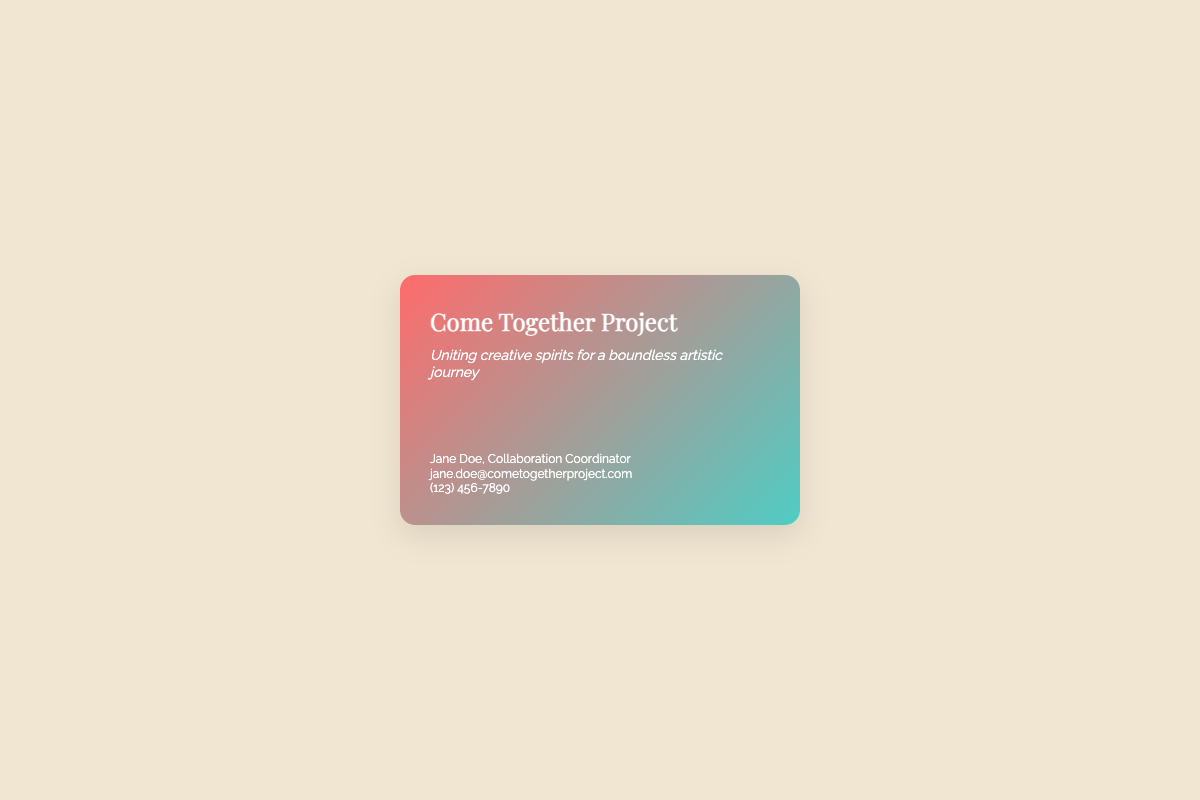What is the name of the project? The name of the project is mentioned prominently at the top of the card.
Answer: Come Together Project Who is the Collaboration Coordinator? The name of the Collaboration Coordinator is clearly stated in the contact section.
Answer: Jane Doe What is the contact email provided? The email for communication is listed in the contact details section.
Answer: jane.doe@cometogetherproject.com What artistic vision does the Come Together Project focus on? The document states that the project focuses on blending diverse artistic visions into a cohesive narrative.
Answer: Cohesive, impactful narrative Which institutions have previously partnered with the project? The back content mentions partners that have worked with the project in the past.
Answer: New Museum, Tate Modern What is the tagline for the Come Together Project? The tagline is included under the project title and captures the essence of the initiative.
Answer: Uniting creative spirits for a boundless artistic journey Where can participants submit their proposals? The document specifies where interested artists can find more information and submit their proposals.
Answer: www.cometogetherproject.com What type of opportunities does the project offer? The document outlines the type of showcases available for artists in the project.
Answer: Collective exhibitions, digital galleries, international art fairs What is the motivational message at the end? The card concludes with a statement that captures the spirit of collaboration in art.
Answer: Together, we redefine the boundaries of art 